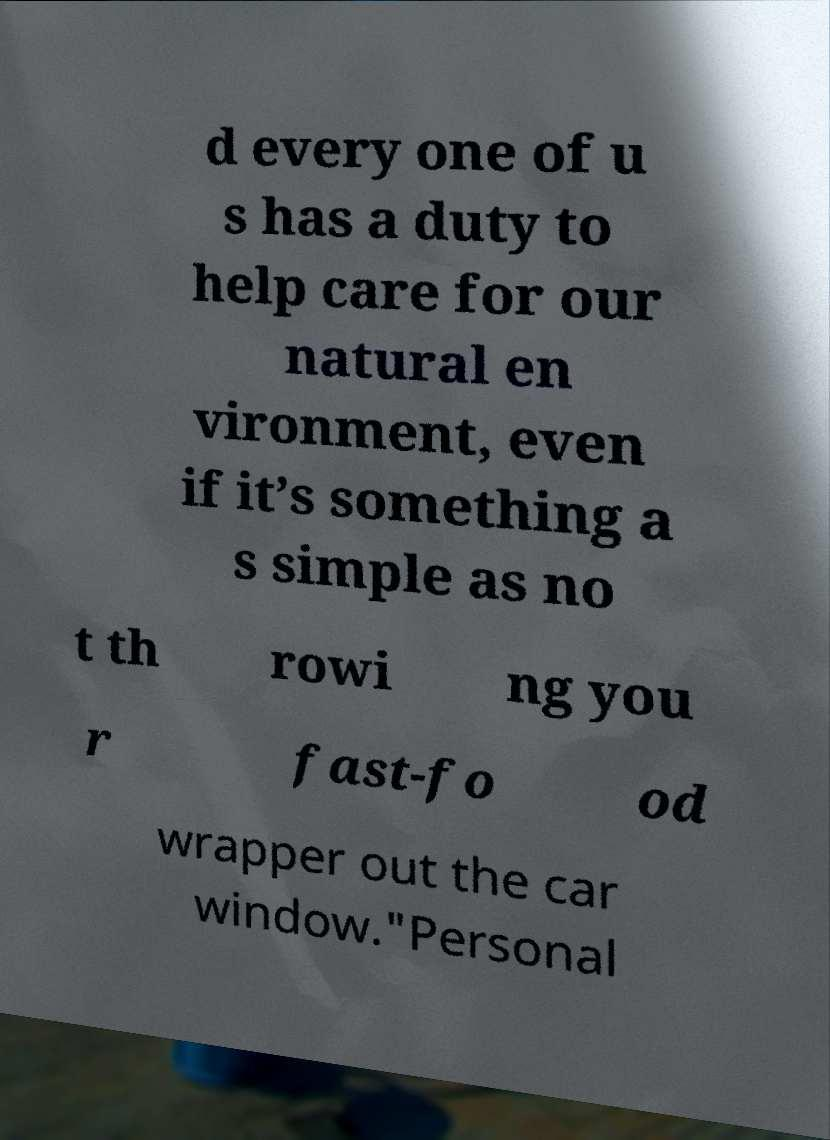Can you accurately transcribe the text from the provided image for me? d every one of u s has a duty to help care for our natural en vironment, even if it’s something a s simple as no t th rowi ng you r fast-fo od wrapper out the car window."Personal 